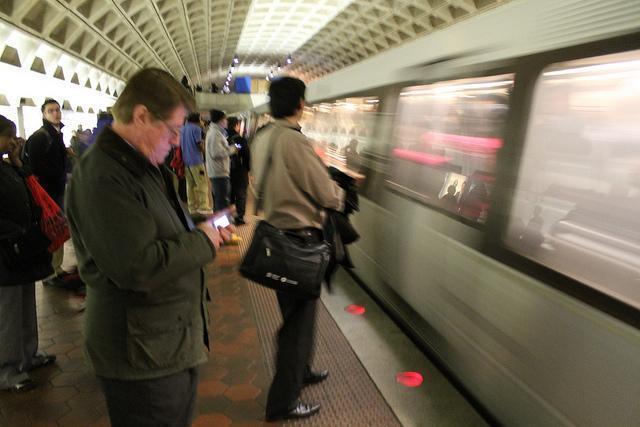How many people are wearing a black bag?
Give a very brief answer. 1. How many backpacks are there?
Give a very brief answer. 2. How many people are there?
Give a very brief answer. 6. 